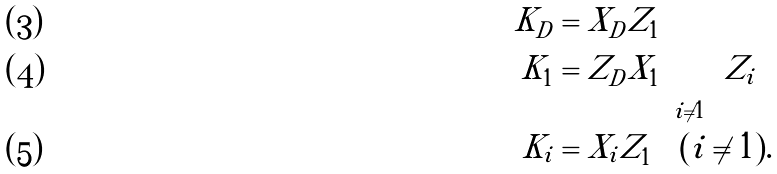<formula> <loc_0><loc_0><loc_500><loc_500>K _ { D } & = X _ { D } Z _ { 1 } \\ K _ { 1 } & = Z _ { D } X _ { 1 } \prod _ { i \ne 1 } Z _ { i } \\ K _ { i } & = X _ { i } Z _ { 1 } \quad ( i \ne 1 ) .</formula> 